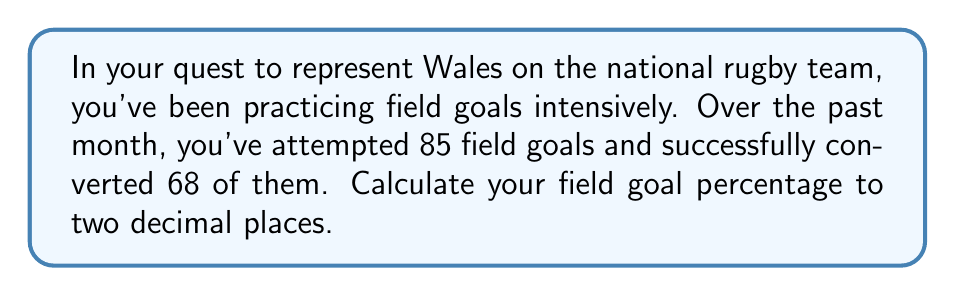Help me with this question. To calculate the field goal percentage, we need to follow these steps:

1. Identify the number of successful field goals: 68
2. Identify the total number of field goal attempts: 85
3. Use the formula for percentage:

   $$ \text{Percentage} = \frac{\text{Number of successful attempts}}{\text{Total number of attempts}} \times 100\% $$

4. Plug in the values:

   $$ \text{Field Goal Percentage} = \frac{68}{85} \times 100\% $$

5. Perform the division:
   
   $$ \frac{68}{85} = 0.8 $$

6. Multiply by 100 to get the percentage:

   $$ 0.8 \times 100\% = 80\% $$

7. Round to two decimal places:

   $$ 80.00\% $$

Therefore, your field goal percentage is 80.00%.
Answer: 80.00% 